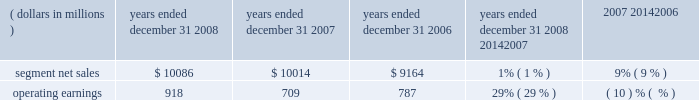Products and software , as well as ongoing investment in next-generation technologies , partially offset by savings from cost-reduction initiatives .
Reorganization of business charges increased due to employee severance costs and expenses related to the exit of a facility .
Sg&a expenses decreased , primarily due to lower marketing expenses and savings from cost-reduction initiatives , partially offset by increased expenditures on information technology upgrades .
As a percentage of net sales in 2007 as compared to 2006 , gross margin and operating margin decreased , and sg&a expenses and r&d expenditures increased .
The segment 2019s backlog was $ 647 million at december 31 , 2007 , compared to $ 1.4 billion at december 31 , 2006 .
This decrease in backlog was primarily due to a decline in customer demand driven by the segment 2019s limited product portfolio .
The segment shipped 159.1 million units in 2007 , a 27% ( 27 % ) decrease compared to shipments of 217.4 million units in 2006 .
The overall decrease reflects decreased unit shipments of products for all technologies .
For the full year 2007 , unit shipments : ( i ) decreased substantially in asia and emea , ( ii ) decreased in north america , and ( iii ) increased in latin america .
Although unit shipments by the segment decreased in 2007 , total unit shipments in the worldwide handset market increased by approximately 16% ( 16 % ) .
The segment estimates its worldwide market share was approximately 14% ( 14 % ) for the full year 2007 , a decrease of approximately 8 percentage points versus full year 2006 .
In 2007 , asp decreased approximately 9% ( 9 % ) compared to 2006 .
The overall decrease in asp was driven primarily by changes in the product-tier and geographic mix of sales .
By comparison , asp decreased approximately 11% ( 11 % ) in 2006 and 10% ( 10 % ) in 2005 .
The segment has several large customers located throughout the world .
In 2007 , aggregate net sales to the segment 2019s five largest customers accounted for approximately 42% ( 42 % ) of the segment 2019s net sales .
Besides selling directly to carriers and operators , the segment also sells products through a variety of third-party distributors and retailers , which account for approximately 33% ( 33 % ) of the segment 2019s net sales .
The largest of these distributors was brightstar corporation .
Although the u.s .
Market continued to be the segment 2019s largest individual market , many of our customers , and more than 54% ( 54 % ) of our segment 2019s 2007 net sales , were outside the u.s .
The largest of these international markets were brazil , china and mexico .
Home and networks mobility segment the home and networks mobility segment designs , manufactures , sells , installs and services : ( i ) digital video , internet protocol video and broadcast network interactive set-tops , end-to-end video delivery systems , broadband access infrastructure platforms , and associated data and voice customer premise equipment to cable television and telecom service providers ( collectively , referred to as the 201chome business 201d ) , and ( ii ) wireless access systems , including cellular infrastructure systems and wireless broadband systems , to wireless service providers ( collectively , referred to as the 201cnetwork business 201d ) .
In 2008 , the segment 2019s net sales represented 33% ( 33 % ) of the company 2019s consolidated net sales , compared to 27% ( 27 % ) in 2007 and 21% ( 21 % ) in 2006 .
( dollars in millions ) 2008 2007 2006 2008 20142007 2007 20142006 years ended december 31 percent change .
Segment results 20142008 compared to 2007 in 2008 , the segment 2019s net sales increased 1% ( 1 % ) to $ 10.1 billion , compared to $ 10.0 billion in 2007 .
The 1% ( 1 % ) increase in net sales primarily reflects a 16% ( 16 % ) increase in net sales in the home business , partially offset by an 11% ( 11 % ) decrease in net sales in the networks business .
The 16% ( 16 % ) increase in net sales in the home business is primarily driven by a 17% ( 17 % ) increase in net sales of digital entertainment devices , reflecting a 19% ( 19 % ) increase in unit shipments to 18.0 million units , partially offset by lower asp due to product mix shift and pricing pressure .
The 11% ( 11 % ) decrease in net sales in the networks business was primarily driven by : ( i ) the absence of net sales by the embedded communication computing group ( 201cecc 201d ) that was divested at the end of 2007 , and ( ii ) lower net sales of iden , gsm and cdma infrastructure equipment , partially offset by higher net sales of umts infrastructure equipment .
On a geographic basis , the 1% ( 1 % ) increase in net sales was primarily driven by higher net sales in latin america and asia , partially offset by lower net sales in north america .
The increase in net sales in latin america was 63management 2019s discussion and analysis of financial condition and results of operations %%transmsg*** transmitting job : c49054 pcn : 066000000 ***%%pcmsg|63 |00024|yes|no|02/24/2009 12:31|0|0|page is valid , no graphics -- color : n| .
How many segmented sales did the 5 largest customers account for in 2008? 
Rationale: the 5 largest customers accounted for $ 4236 million in 2008 . to figure this out you multiple the 2008 segmented sales by the percentage given in line 16 .
Computations: (10086 * 42%)
Answer: 4236.12. 